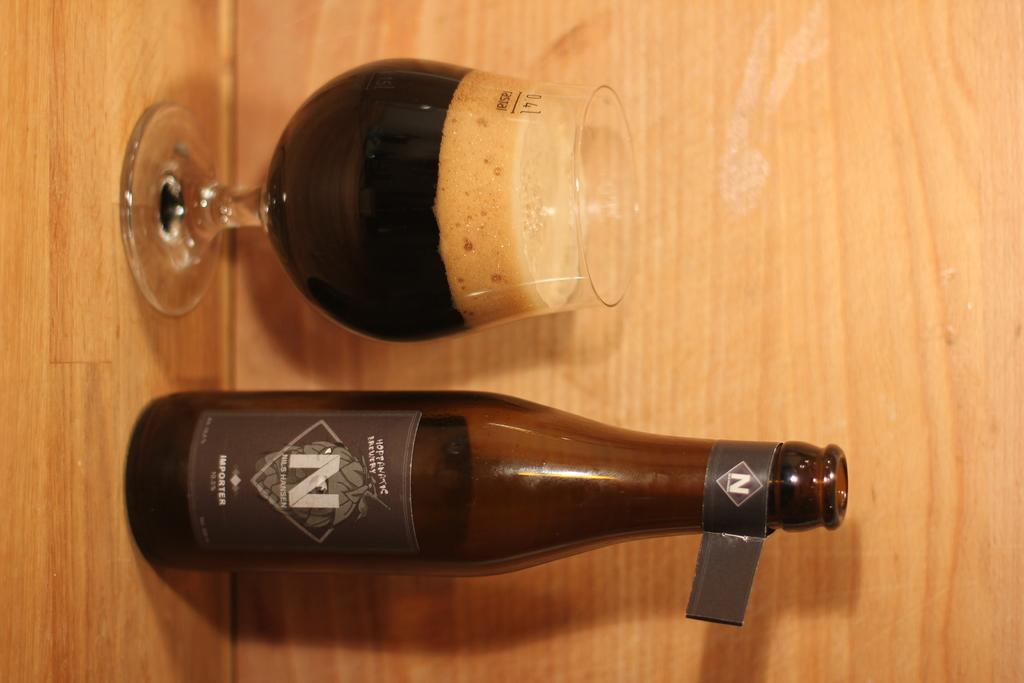<image>
Present a compact description of the photo's key features. A bottle and glass of Nils Hansen importer beer. 